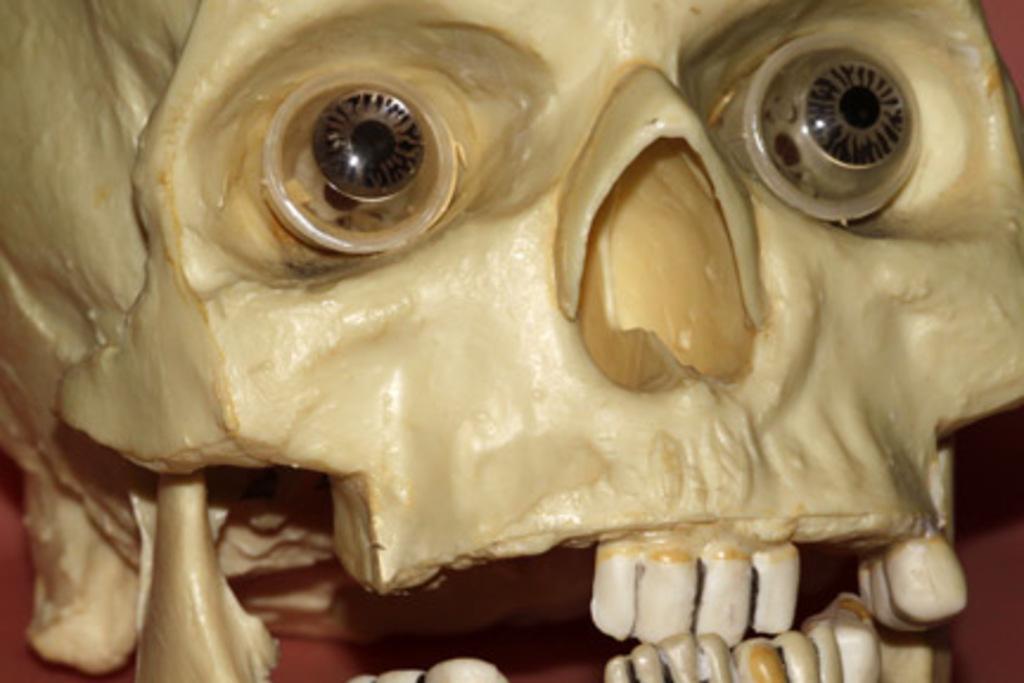Can you describe this image briefly? In this image there is a sculpture of a skull. 